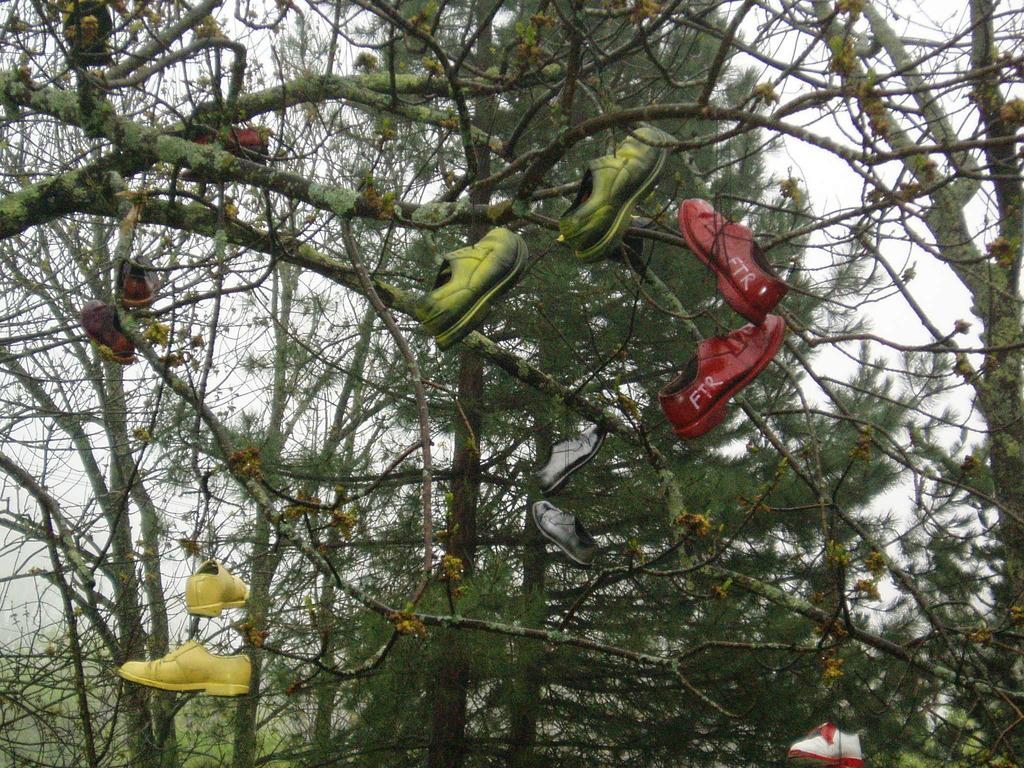What objects are hanging from the tree branches in the image? There are pairs of shoes hanging from tree branches in the image. What can be seen in the background of the image? The sky is visible in the background of the image. What type of things can be seen rubbing against each other in the image? There is no indication in the image of any objects rubbing against each other. 